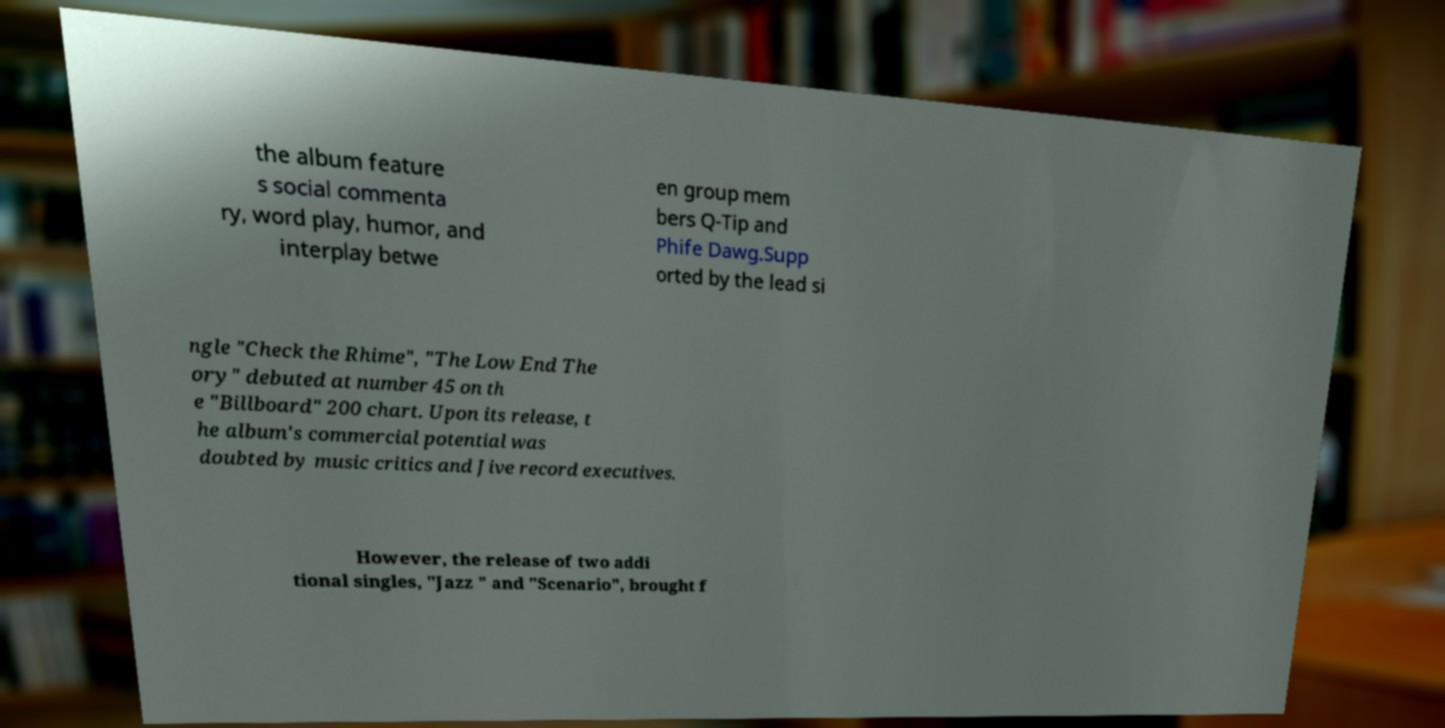I need the written content from this picture converted into text. Can you do that? the album feature s social commenta ry, word play, humor, and interplay betwe en group mem bers Q-Tip and Phife Dawg.Supp orted by the lead si ngle "Check the Rhime", "The Low End The ory" debuted at number 45 on th e "Billboard" 200 chart. Upon its release, t he album's commercial potential was doubted by music critics and Jive record executives. However, the release of two addi tional singles, "Jazz " and "Scenario", brought f 